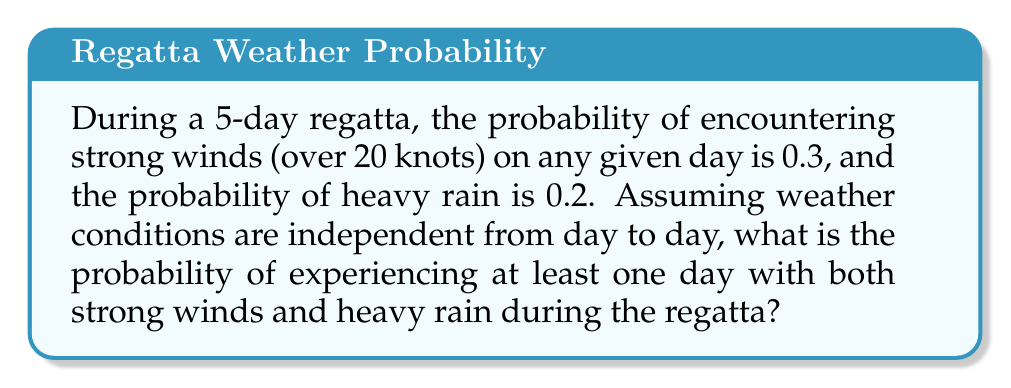Give your solution to this math problem. Let's approach this step-by-step:

1) First, we need to calculate the probability of having both strong winds and heavy rain on a single day:
   $P(\text{strong winds and heavy rain}) = 0.3 \times 0.2 = 0.06$

2) Now, let's calculate the probability of not having both conditions on a single day:
   $P(\text{not both}) = 1 - 0.06 = 0.94$

3) For the entire regatta, we want the probability of having at least one day with both conditions. This is equivalent to 1 minus the probability of having no days with both conditions.

4) The probability of having no days with both conditions over 5 days is:
   $P(\text{no days with both}) = 0.94^5$

5) Therefore, the probability of having at least one day with both conditions is:
   $P(\text{at least one day with both}) = 1 - 0.94^5$

6) Let's calculate this:
   $1 - 0.94^5 = 1 - 0.7351995646 = 0.2648004354$

7) Rounding to four decimal places:
   $0.2648$

Thus, there is approximately a 26.48% chance of experiencing at least one day with both strong winds and heavy rain during the 5-day regatta.
Answer: $0.2648$ or $26.48\%$ 